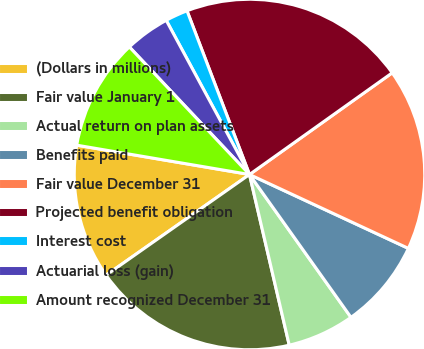Convert chart. <chart><loc_0><loc_0><loc_500><loc_500><pie_chart><fcel>(Dollars in millions)<fcel>Fair value January 1<fcel>Actual return on plan assets<fcel>Benefits paid<fcel>Fair value December 31<fcel>Projected benefit obligation<fcel>Interest cost<fcel>Actuarial loss (gain)<fcel>Amount recognized December 31<nl><fcel>12.42%<fcel>18.9%<fcel>6.19%<fcel>8.24%<fcel>16.78%<fcel>20.95%<fcel>2.08%<fcel>4.14%<fcel>10.3%<nl></chart> 